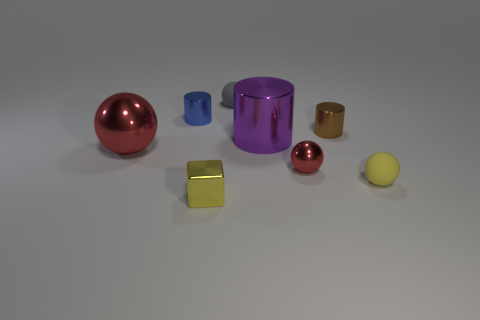How many other objects are the same color as the tiny shiny block?
Keep it short and to the point. 1. The gray object that is on the left side of the big purple metal cylinder has what shape?
Ensure brevity in your answer.  Sphere. How many big cubes are the same material as the tiny yellow cube?
Provide a short and direct response. 0. Is the number of metallic cylinders in front of the yellow rubber sphere less than the number of big purple shiny objects?
Make the answer very short. Yes. There is a red object left of the shiny object in front of the small metallic ball; what is its size?
Your response must be concise. Large. There is a tiny shiny sphere; is it the same color as the matte thing behind the yellow ball?
Keep it short and to the point. No. There is a brown object that is the same size as the gray rubber thing; what material is it?
Provide a short and direct response. Metal. Are there fewer shiny cylinders behind the small brown metal cylinder than matte objects that are to the left of the small gray ball?
Your answer should be compact. No. The big object that is to the left of the matte sphere on the left side of the tiny brown shiny object is what shape?
Offer a terse response. Sphere. Is there a red object?
Your response must be concise. Yes. 